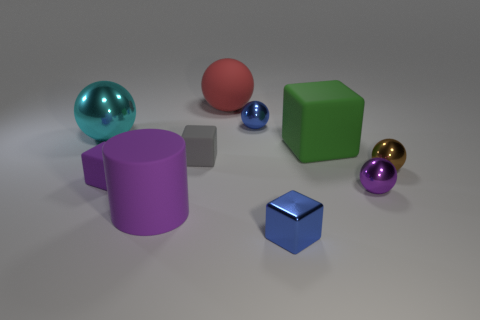Subtract all green cubes. How many cubes are left? 3 Subtract 0 yellow spheres. How many objects are left? 10 Subtract all cubes. How many objects are left? 6 Subtract 2 balls. How many balls are left? 3 Subtract all blue cubes. Subtract all cyan cylinders. How many cubes are left? 3 Subtract all red cylinders. How many red spheres are left? 1 Subtract all gray shiny cubes. Subtract all blue shiny objects. How many objects are left? 8 Add 2 metal blocks. How many metal blocks are left? 3 Add 2 gray blocks. How many gray blocks exist? 3 Subtract all blue blocks. How many blocks are left? 3 